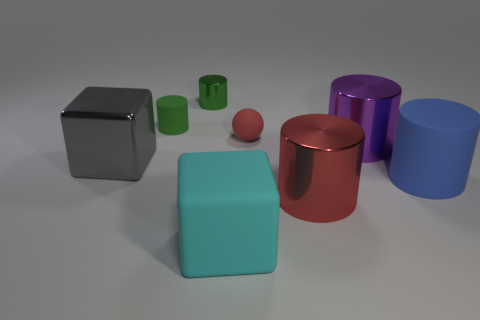How many cylinders are either big rubber objects or tiny objects?
Offer a terse response. 3. There is a big rubber thing behind the large rubber block; what color is it?
Give a very brief answer. Blue. What is the shape of the large shiny object that is the same color as the tiny rubber ball?
Your answer should be very brief. Cylinder. What number of gray metallic blocks are the same size as the cyan cube?
Provide a short and direct response. 1. There is a red object that is in front of the big gray object; is it the same shape as the tiny object that is to the right of the big cyan matte thing?
Offer a very short reply. No. There is a big cylinder that is behind the large object that is to the left of the matte thing in front of the big red metallic object; what is it made of?
Your answer should be compact. Metal. There is a metallic thing that is the same size as the red matte object; what is its shape?
Your answer should be very brief. Cylinder. Is there a rubber object that has the same color as the metal block?
Keep it short and to the point. No. What is the size of the gray shiny object?
Keep it short and to the point. Large. Is the material of the red cylinder the same as the big gray thing?
Ensure brevity in your answer.  Yes. 